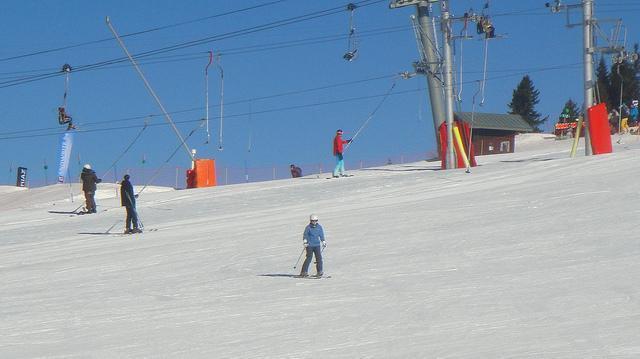How many beds are under the lamp?
Give a very brief answer. 0. 